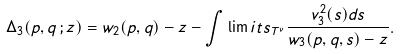<formula> <loc_0><loc_0><loc_500><loc_500>\Delta _ { 3 } ( p , q \, ; z ) = w _ { 2 } ( p , q ) - z - \int \lim i t s _ { { T } ^ { \nu } } \frac { v _ { 3 } ^ { 2 } ( s ) d s } { w _ { 3 } ( p , q , s ) - z } .</formula> 